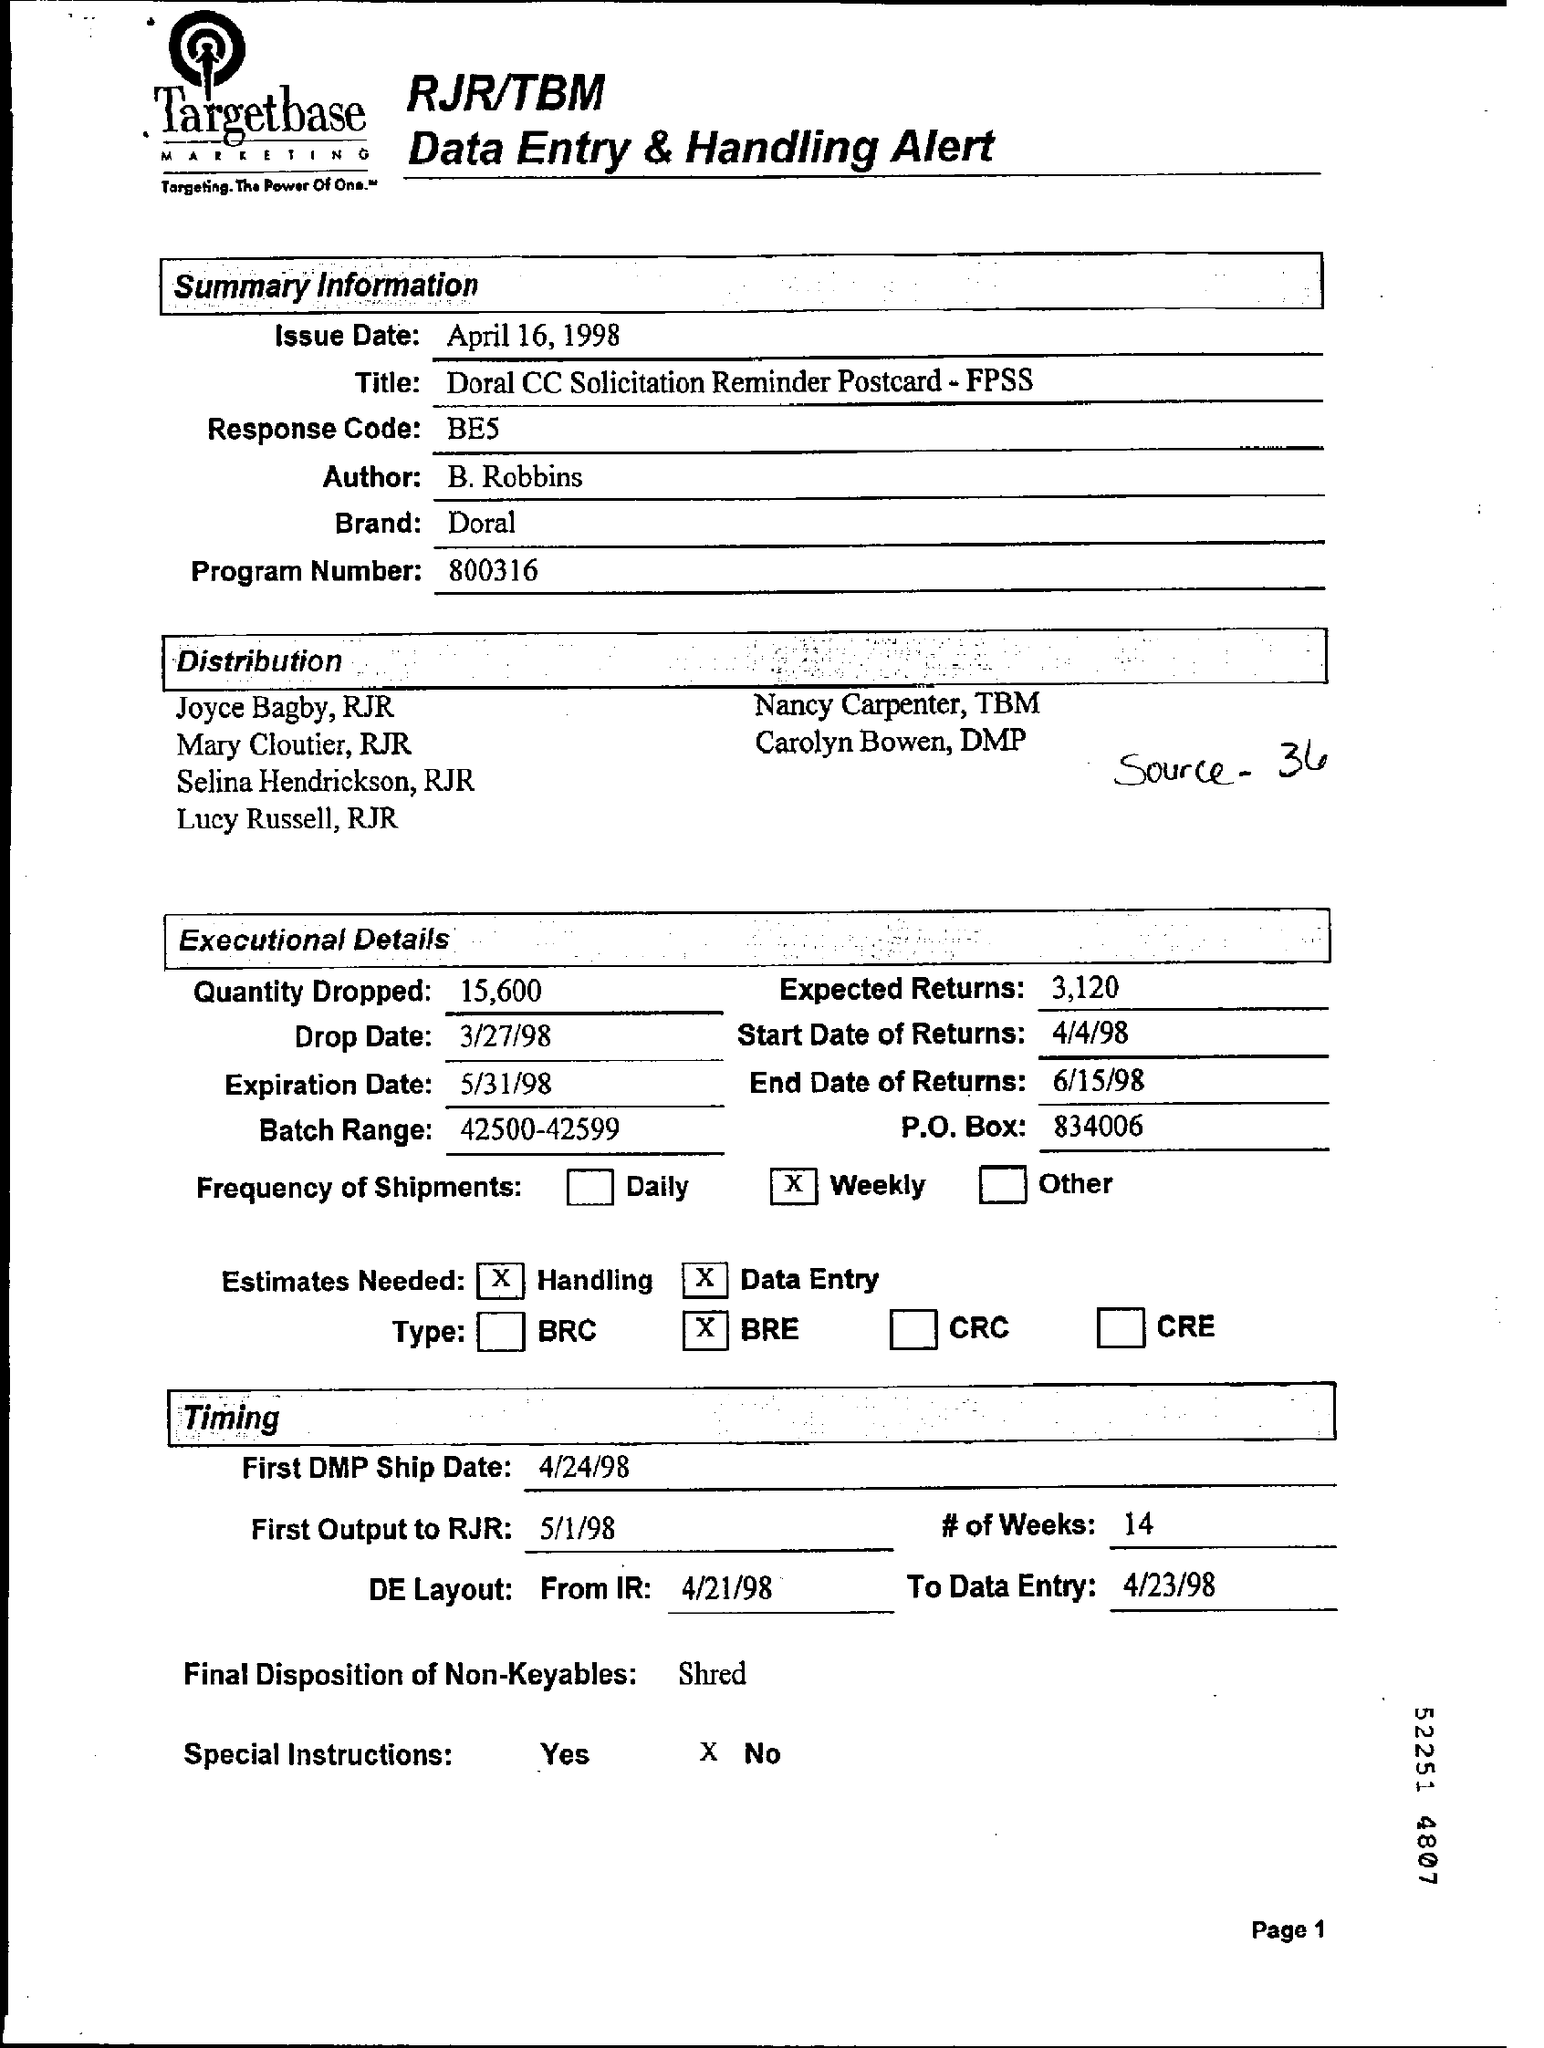Specify some key components in this picture. The response code refers to a specific numerical code that is generated in response to a particular action or event. The phrase "What is the 'Title' ? Doral CC Solicitation Reminder Postcard - FPSS.." is a nonsense phrase and does not convey any specific meaning. It is not clear what the intended message is or what it is intended to convey. The frequency of shipments is weekly. The batch range is 42,500 to 42,599, inclusive. The program is called 'Number' and it is 800316. 